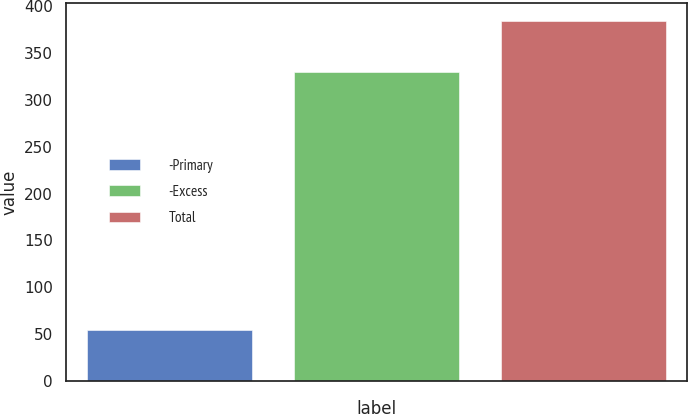Convert chart to OTSL. <chart><loc_0><loc_0><loc_500><loc_500><bar_chart><fcel>-Primary<fcel>-Excess<fcel>Total<nl><fcel>54<fcel>330<fcel>384<nl></chart> 